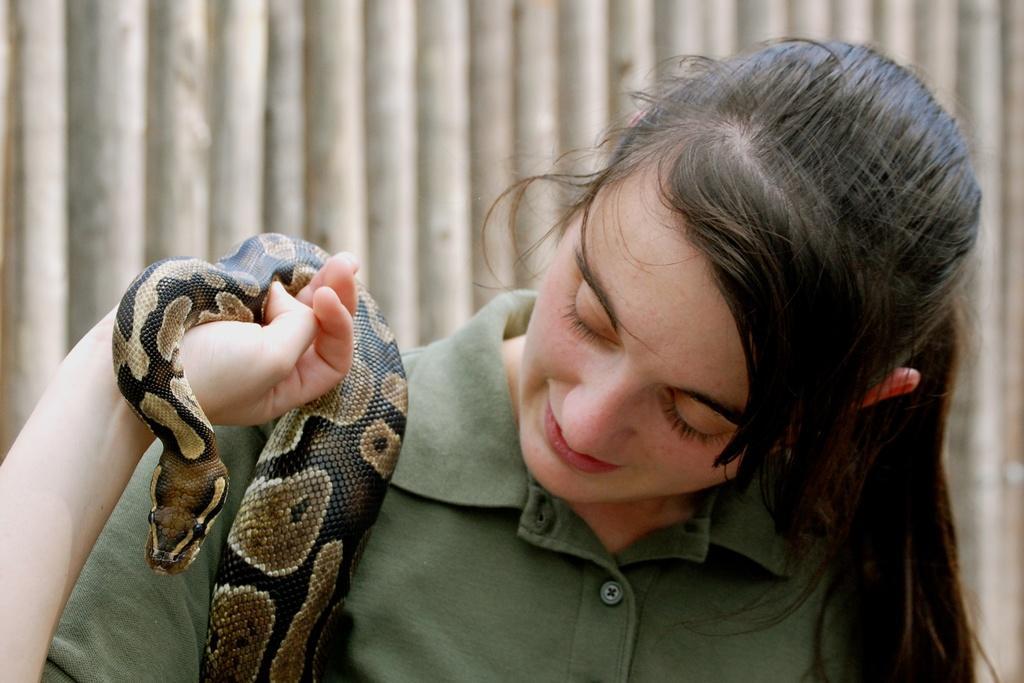Can you describe this image briefly? In this image I can see the person wearing the green color dress and holding the snake which is in black and brown color. And there is an ash color background. 